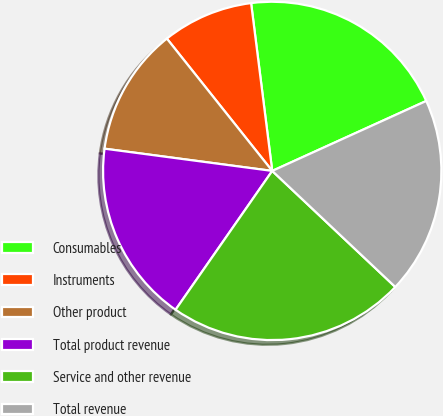Convert chart to OTSL. <chart><loc_0><loc_0><loc_500><loc_500><pie_chart><fcel>Consumables<fcel>Instruments<fcel>Other product<fcel>Total product revenue<fcel>Service and other revenue<fcel>Total revenue<nl><fcel>20.21%<fcel>8.71%<fcel>12.2%<fcel>17.42%<fcel>22.65%<fcel>18.82%<nl></chart> 